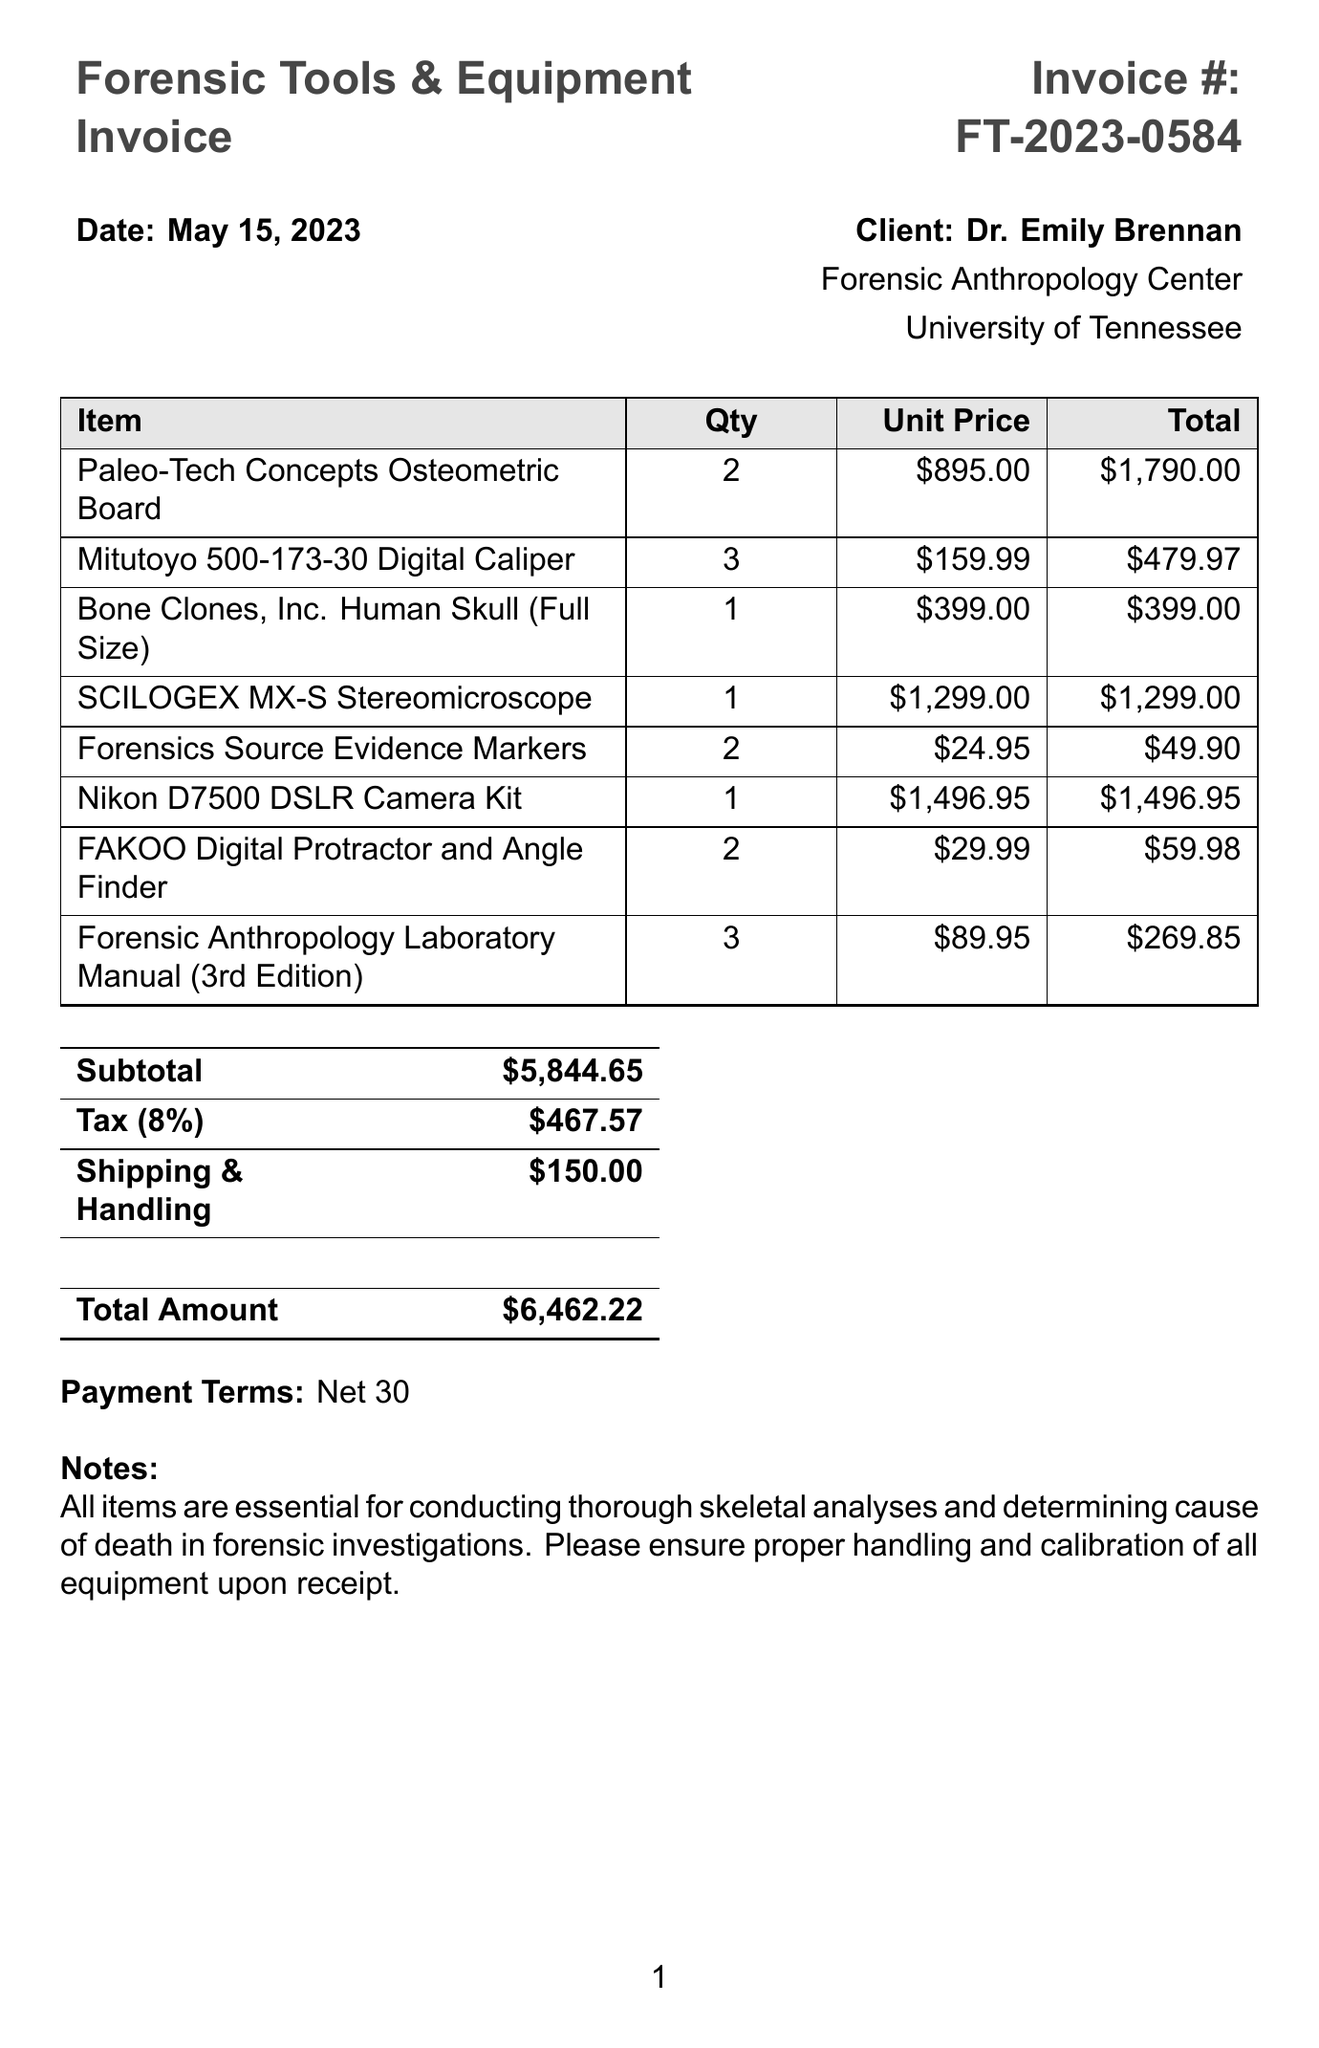What is the invoice number? The invoice number is provided at the top of the document, which is FT-2023-0584.
Answer: FT-2023-0584 Who is the client? The client's name is indicated in the document, which states Dr. Emily Brennan.
Answer: Dr. Emily Brennan What is the date of the invoice? The date is specified in the document, noted as May 15, 2023.
Answer: May 15, 2023 What is the total amount due? The total amount is summarized in the final section of the invoice, which amounts to 6462.22.
Answer: 6462.22 How many Paleo-Tech Concepts Osteometric Boards were purchased? The quantity of this item is detailed in the invoice, which indicates there were 2 purchased.
Answer: 2 What percentage is the tax rate? The tax rate is specified in the document, which is 8 percent.
Answer: 8% What type of microscope is included in the invoice? The type of microscope listed on the invoice is a SCILOGEX MX-S Stereomicroscope.
Answer: SCILOGEX MX-S Stereomicroscope What is the payment term specified in the document? The payment terms are indicated towards the end of the invoice, which states Net 30.
Answer: Net 30 Why are these items deemed essential, according to the notes? The notes explain that the items are necessary for conducting thorough skeletal analyses and determining cause of death.
Answer: Conducting thorough skeletal analyses and determining cause of death 